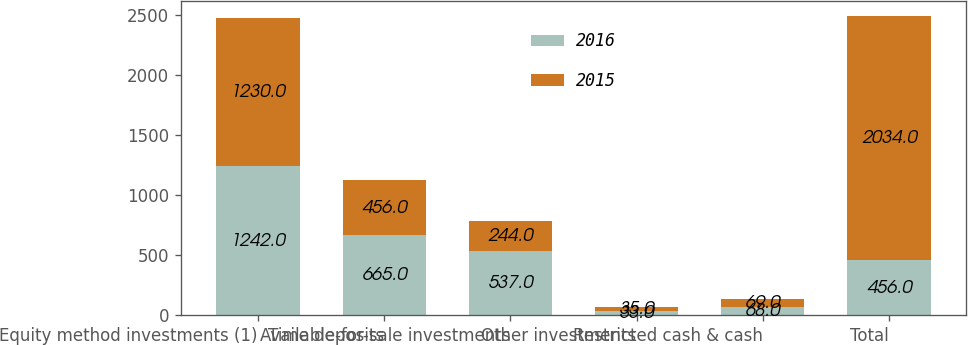<chart> <loc_0><loc_0><loc_500><loc_500><stacked_bar_chart><ecel><fcel>Equity method investments (1)<fcel>Time deposits<fcel>Available-for-sale investments<fcel>Other investments<fcel>Restricted cash & cash<fcel>Total<nl><fcel>2016<fcel>1242<fcel>665<fcel>537<fcel>33<fcel>68<fcel>456<nl><fcel>2015<fcel>1230<fcel>456<fcel>244<fcel>35<fcel>69<fcel>2034<nl></chart> 